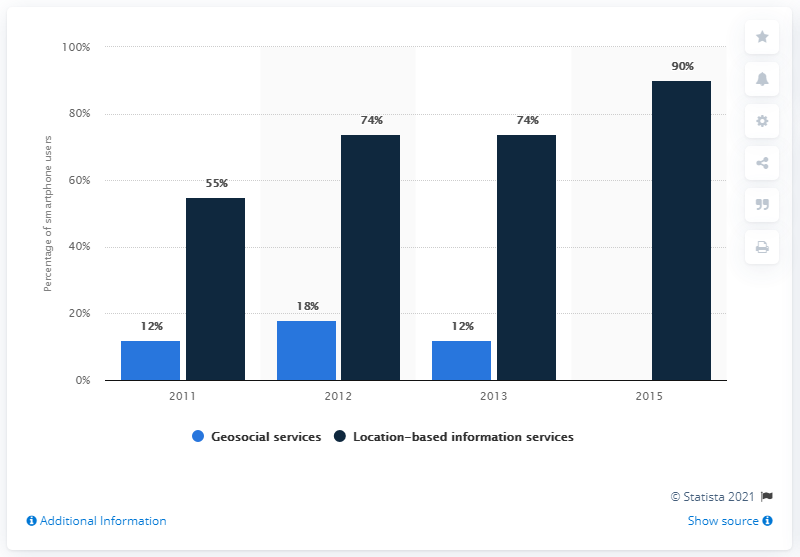Point out several critical features in this image. In 2015, there was no value in geosocial services. The average share of location-based information services is 73.25%. 